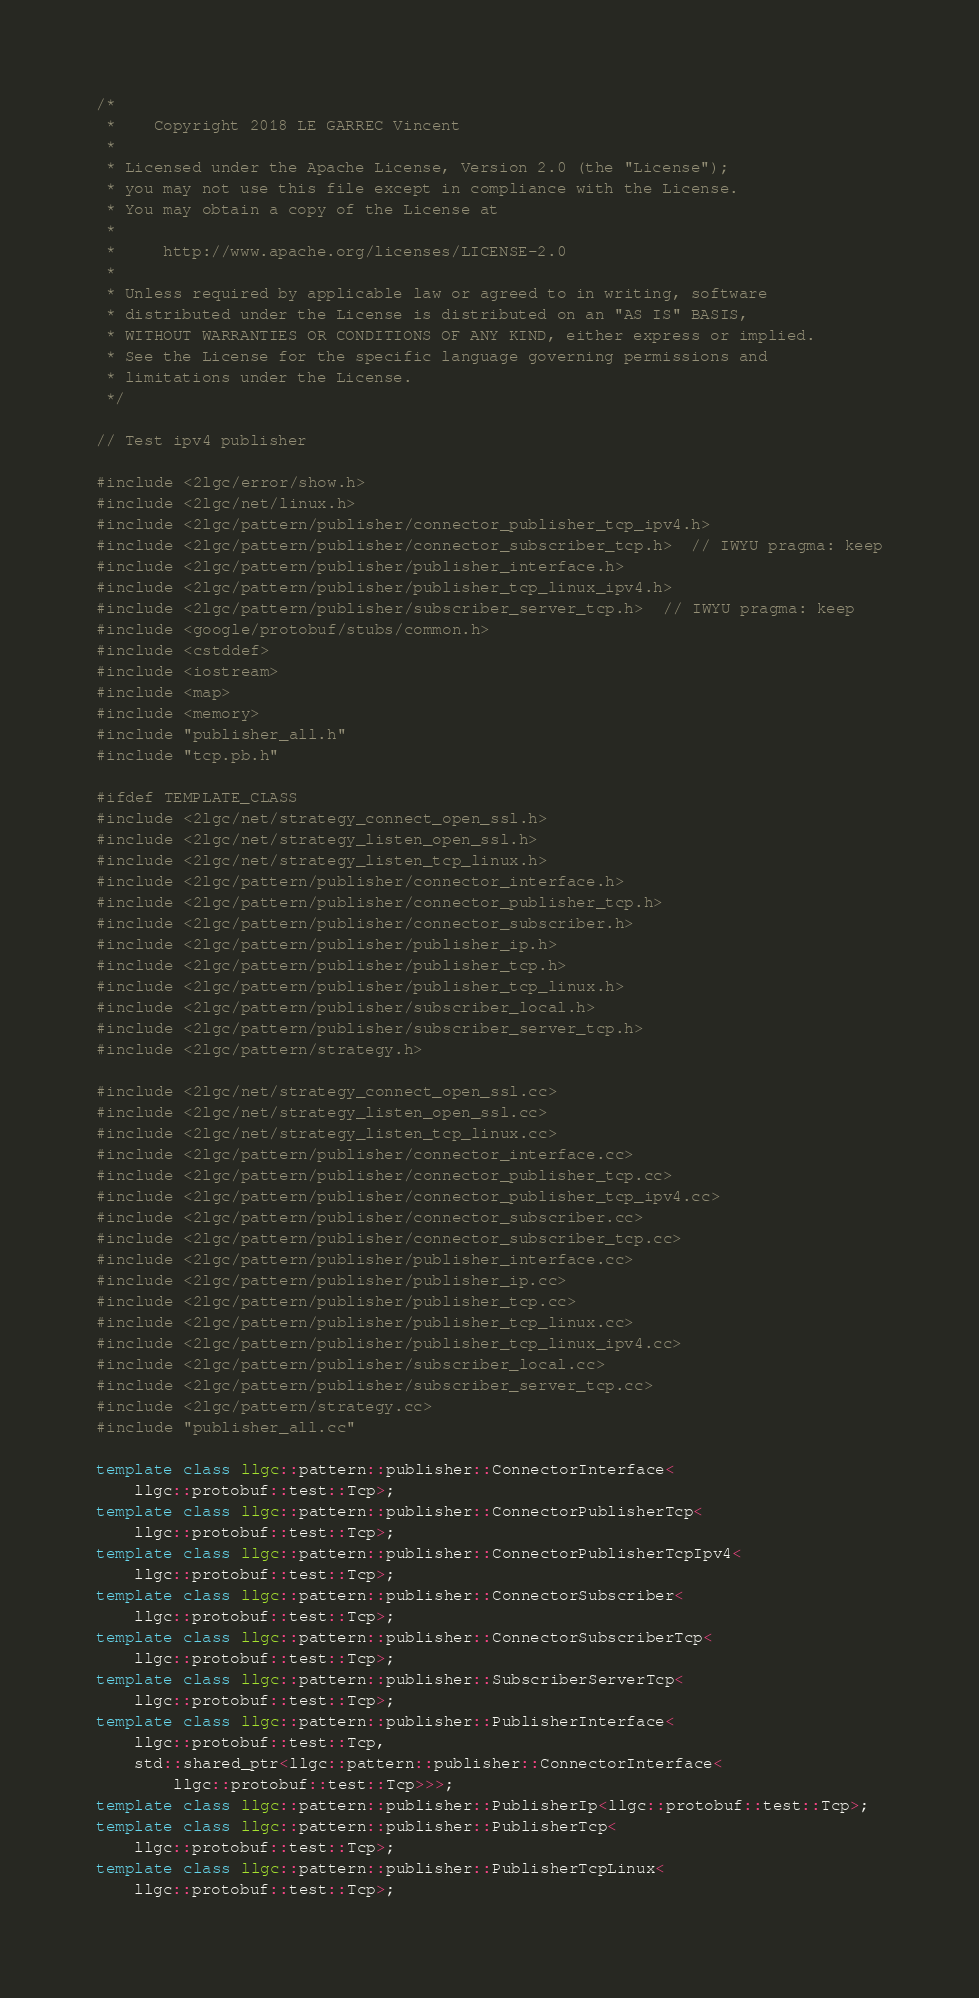Convert code to text. <code><loc_0><loc_0><loc_500><loc_500><_C++_>/*
 *    Copyright 2018 LE GARREC Vincent
 *
 * Licensed under the Apache License, Version 2.0 (the "License");
 * you may not use this file except in compliance with the License.
 * You may obtain a copy of the License at
 *
 *     http://www.apache.org/licenses/LICENSE-2.0
 *
 * Unless required by applicable law or agreed to in writing, software
 * distributed under the License is distributed on an "AS IS" BASIS,
 * WITHOUT WARRANTIES OR CONDITIONS OF ANY KIND, either express or implied.
 * See the License for the specific language governing permissions and
 * limitations under the License.
 */

// Test ipv4 publisher

#include <2lgc/error/show.h>
#include <2lgc/net/linux.h>
#include <2lgc/pattern/publisher/connector_publisher_tcp_ipv4.h>
#include <2lgc/pattern/publisher/connector_subscriber_tcp.h>  // IWYU pragma: keep
#include <2lgc/pattern/publisher/publisher_interface.h>
#include <2lgc/pattern/publisher/publisher_tcp_linux_ipv4.h>
#include <2lgc/pattern/publisher/subscriber_server_tcp.h>  // IWYU pragma: keep
#include <google/protobuf/stubs/common.h>
#include <cstddef>
#include <iostream>
#include <map>
#include <memory>
#include "publisher_all.h"
#include "tcp.pb.h"

#ifdef TEMPLATE_CLASS
#include <2lgc/net/strategy_connect_open_ssl.h>
#include <2lgc/net/strategy_listen_open_ssl.h>
#include <2lgc/net/strategy_listen_tcp_linux.h>
#include <2lgc/pattern/publisher/connector_interface.h>
#include <2lgc/pattern/publisher/connector_publisher_tcp.h>
#include <2lgc/pattern/publisher/connector_subscriber.h>
#include <2lgc/pattern/publisher/publisher_ip.h>
#include <2lgc/pattern/publisher/publisher_tcp.h>
#include <2lgc/pattern/publisher/publisher_tcp_linux.h>
#include <2lgc/pattern/publisher/subscriber_local.h>
#include <2lgc/pattern/publisher/subscriber_server_tcp.h>
#include <2lgc/pattern/strategy.h>

#include <2lgc/net/strategy_connect_open_ssl.cc>
#include <2lgc/net/strategy_listen_open_ssl.cc>
#include <2lgc/net/strategy_listen_tcp_linux.cc>
#include <2lgc/pattern/publisher/connector_interface.cc>
#include <2lgc/pattern/publisher/connector_publisher_tcp.cc>
#include <2lgc/pattern/publisher/connector_publisher_tcp_ipv4.cc>
#include <2lgc/pattern/publisher/connector_subscriber.cc>
#include <2lgc/pattern/publisher/connector_subscriber_tcp.cc>
#include <2lgc/pattern/publisher/publisher_interface.cc>
#include <2lgc/pattern/publisher/publisher_ip.cc>
#include <2lgc/pattern/publisher/publisher_tcp.cc>
#include <2lgc/pattern/publisher/publisher_tcp_linux.cc>
#include <2lgc/pattern/publisher/publisher_tcp_linux_ipv4.cc>
#include <2lgc/pattern/publisher/subscriber_local.cc>
#include <2lgc/pattern/publisher/subscriber_server_tcp.cc>
#include <2lgc/pattern/strategy.cc>
#include "publisher_all.cc"

template class llgc::pattern::publisher::ConnectorInterface<
    llgc::protobuf::test::Tcp>;
template class llgc::pattern::publisher::ConnectorPublisherTcp<
    llgc::protobuf::test::Tcp>;
template class llgc::pattern::publisher::ConnectorPublisherTcpIpv4<
    llgc::protobuf::test::Tcp>;
template class llgc::pattern::publisher::ConnectorSubscriber<
    llgc::protobuf::test::Tcp>;
template class llgc::pattern::publisher::ConnectorSubscriberTcp<
    llgc::protobuf::test::Tcp>;
template class llgc::pattern::publisher::SubscriberServerTcp<
    llgc::protobuf::test::Tcp>;
template class llgc::pattern::publisher::PublisherInterface<
    llgc::protobuf::test::Tcp,
    std::shared_ptr<llgc::pattern::publisher::ConnectorInterface<
        llgc::protobuf::test::Tcp>>>;
template class llgc::pattern::publisher::PublisherIp<llgc::protobuf::test::Tcp>;
template class llgc::pattern::publisher::PublisherTcp<
    llgc::protobuf::test::Tcp>;
template class llgc::pattern::publisher::PublisherTcpLinux<
    llgc::protobuf::test::Tcp>;</code> 